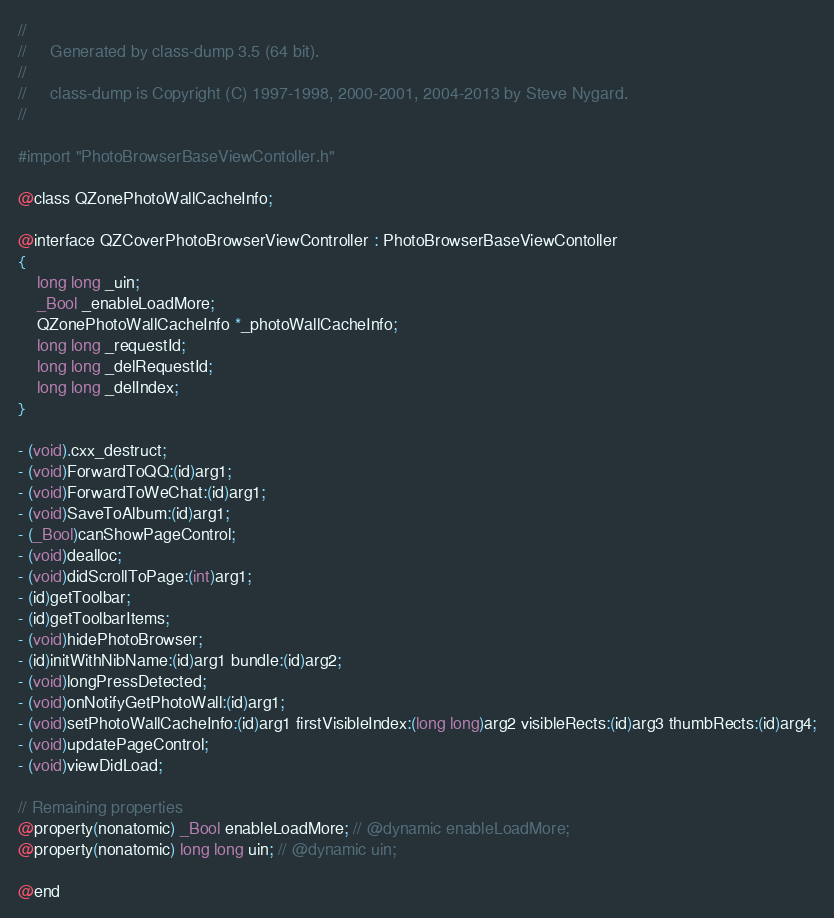<code> <loc_0><loc_0><loc_500><loc_500><_C_>//
//     Generated by class-dump 3.5 (64 bit).
//
//     class-dump is Copyright (C) 1997-1998, 2000-2001, 2004-2013 by Steve Nygard.
//

#import "PhotoBrowserBaseViewContoller.h"

@class QZonePhotoWallCacheInfo;

@interface QZCoverPhotoBrowserViewController : PhotoBrowserBaseViewContoller
{
    long long _uin;
    _Bool _enableLoadMore;
    QZonePhotoWallCacheInfo *_photoWallCacheInfo;
    long long _requestId;
    long long _delRequestId;
    long long _delIndex;
}

- (void).cxx_destruct;
- (void)ForwardToQQ:(id)arg1;
- (void)ForwardToWeChat:(id)arg1;
- (void)SaveToAlbum:(id)arg1;
- (_Bool)canShowPageControl;
- (void)dealloc;
- (void)didScrollToPage:(int)arg1;
- (id)getToolbar;
- (id)getToolbarItems;
- (void)hidePhotoBrowser;
- (id)initWithNibName:(id)arg1 bundle:(id)arg2;
- (void)longPressDetected;
- (void)onNotifyGetPhotoWall:(id)arg1;
- (void)setPhotoWallCacheInfo:(id)arg1 firstVisibleIndex:(long long)arg2 visibleRects:(id)arg3 thumbRects:(id)arg4;
- (void)updatePageControl;
- (void)viewDidLoad;

// Remaining properties
@property(nonatomic) _Bool enableLoadMore; // @dynamic enableLoadMore;
@property(nonatomic) long long uin; // @dynamic uin;

@end

</code> 